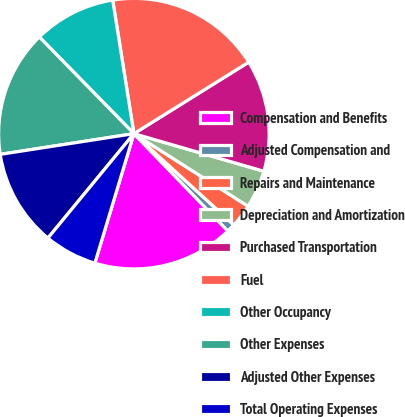Convert chart to OTSL. <chart><loc_0><loc_0><loc_500><loc_500><pie_chart><fcel>Compensation and Benefits<fcel>Adjusted Compensation and<fcel>Repairs and Maintenance<fcel>Depreciation and Amortization<fcel>Purchased Transportation<fcel>Fuel<fcel>Other Occupancy<fcel>Other Expenses<fcel>Adjusted Other Expenses<fcel>Total Operating Expenses<nl><fcel>16.88%<fcel>1.0%<fcel>2.77%<fcel>4.53%<fcel>13.35%<fcel>18.64%<fcel>9.82%<fcel>15.12%<fcel>11.59%<fcel>6.3%<nl></chart> 